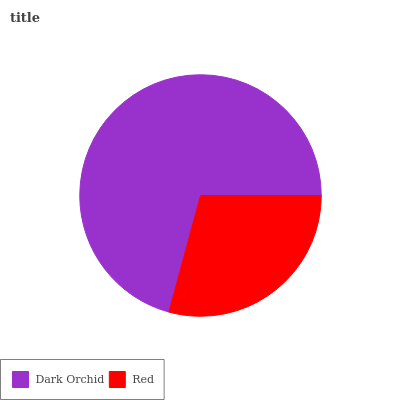Is Red the minimum?
Answer yes or no. Yes. Is Dark Orchid the maximum?
Answer yes or no. Yes. Is Red the maximum?
Answer yes or no. No. Is Dark Orchid greater than Red?
Answer yes or no. Yes. Is Red less than Dark Orchid?
Answer yes or no. Yes. Is Red greater than Dark Orchid?
Answer yes or no. No. Is Dark Orchid less than Red?
Answer yes or no. No. Is Dark Orchid the high median?
Answer yes or no. Yes. Is Red the low median?
Answer yes or no. Yes. Is Red the high median?
Answer yes or no. No. Is Dark Orchid the low median?
Answer yes or no. No. 